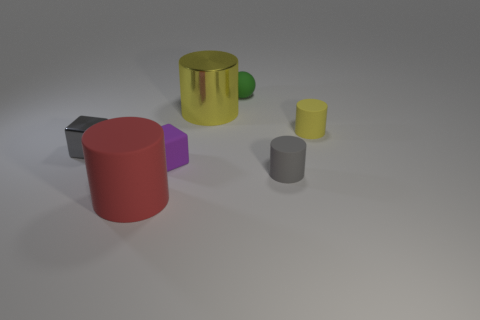What colors are present in the image? The image showcases a palette of colors including red, purple, gray, yellow, and green. Which object seems to be the largest? The red cylinder looks to be the largest object in terms of volume in the image. 